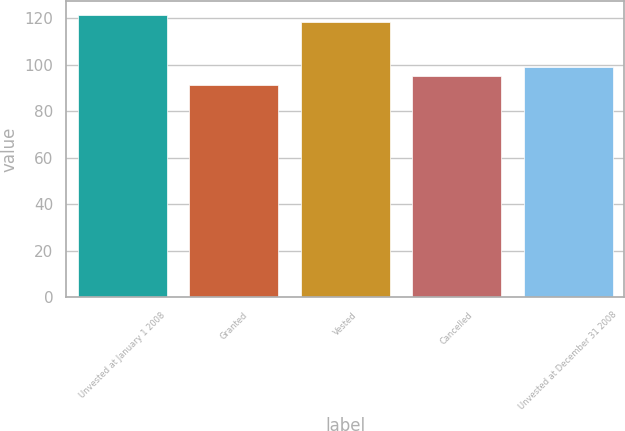Convert chart. <chart><loc_0><loc_0><loc_500><loc_500><bar_chart><fcel>Unvested at January 1 2008<fcel>Granted<fcel>Vested<fcel>Cancelled<fcel>Unvested at December 31 2008<nl><fcel>121.31<fcel>91.28<fcel>118.26<fcel>95.13<fcel>98.97<nl></chart> 